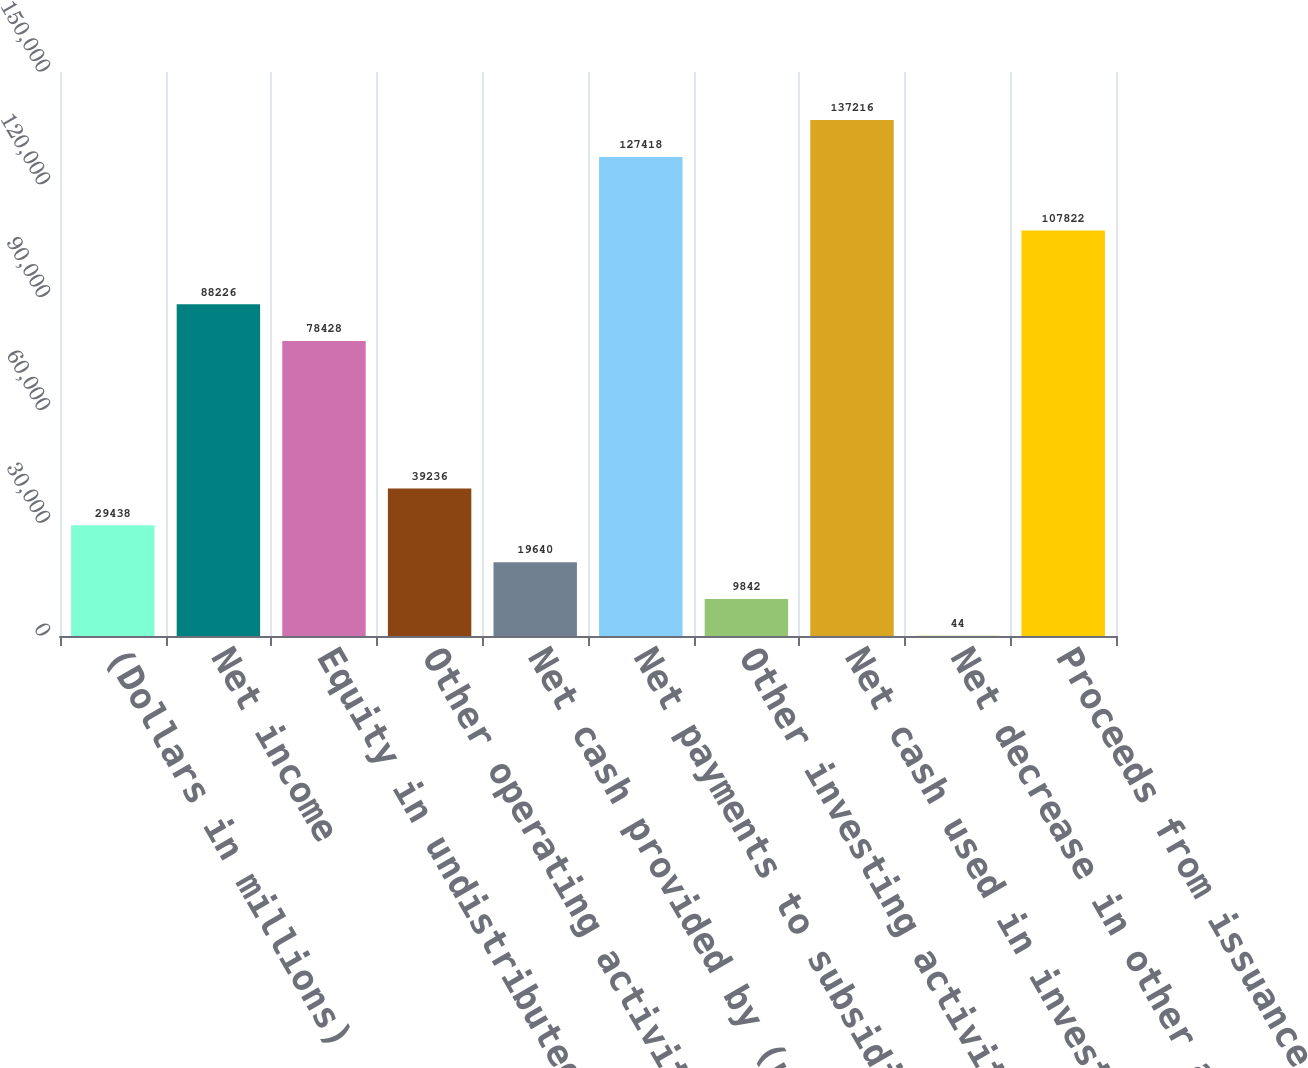<chart> <loc_0><loc_0><loc_500><loc_500><bar_chart><fcel>(Dollars in millions)<fcel>Net income<fcel>Equity in undistributed<fcel>Other operating activities net<fcel>Net cash provided by (used in)<fcel>Net payments to subsidiaries<fcel>Other investing activities net<fcel>Net cash used in investing<fcel>Net decrease in other advances<fcel>Proceeds from issuance of<nl><fcel>29438<fcel>88226<fcel>78428<fcel>39236<fcel>19640<fcel>127418<fcel>9842<fcel>137216<fcel>44<fcel>107822<nl></chart> 